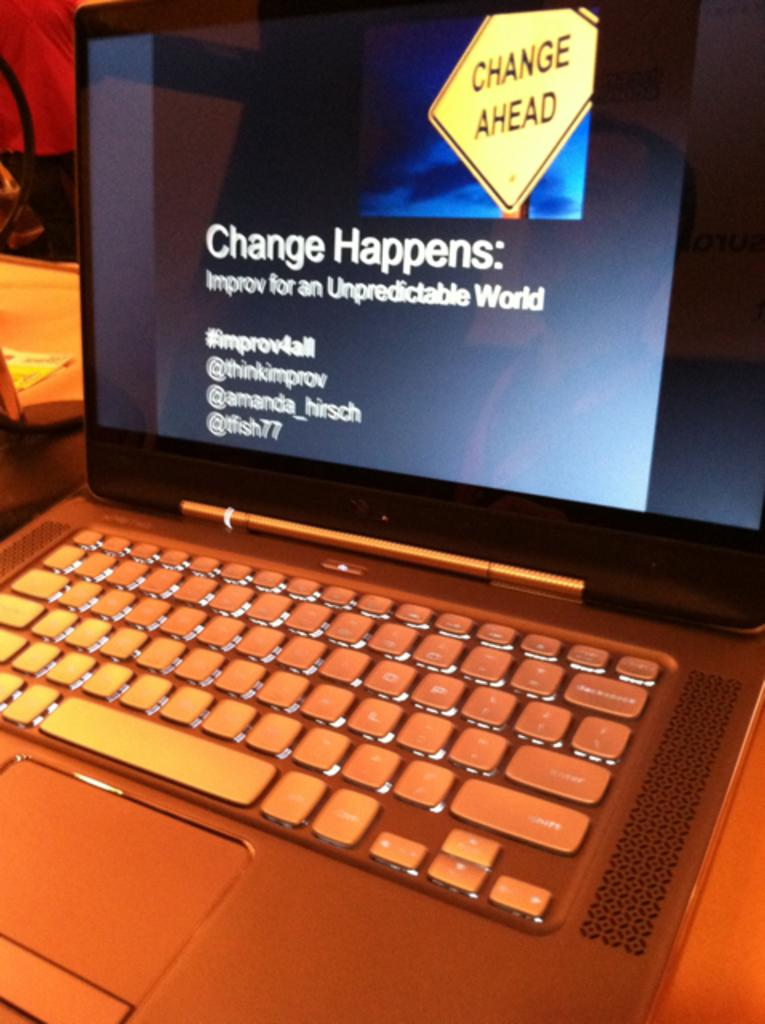<image>
Summarize the visual content of the image. A computer monitor with a message that says "Change Happens" 